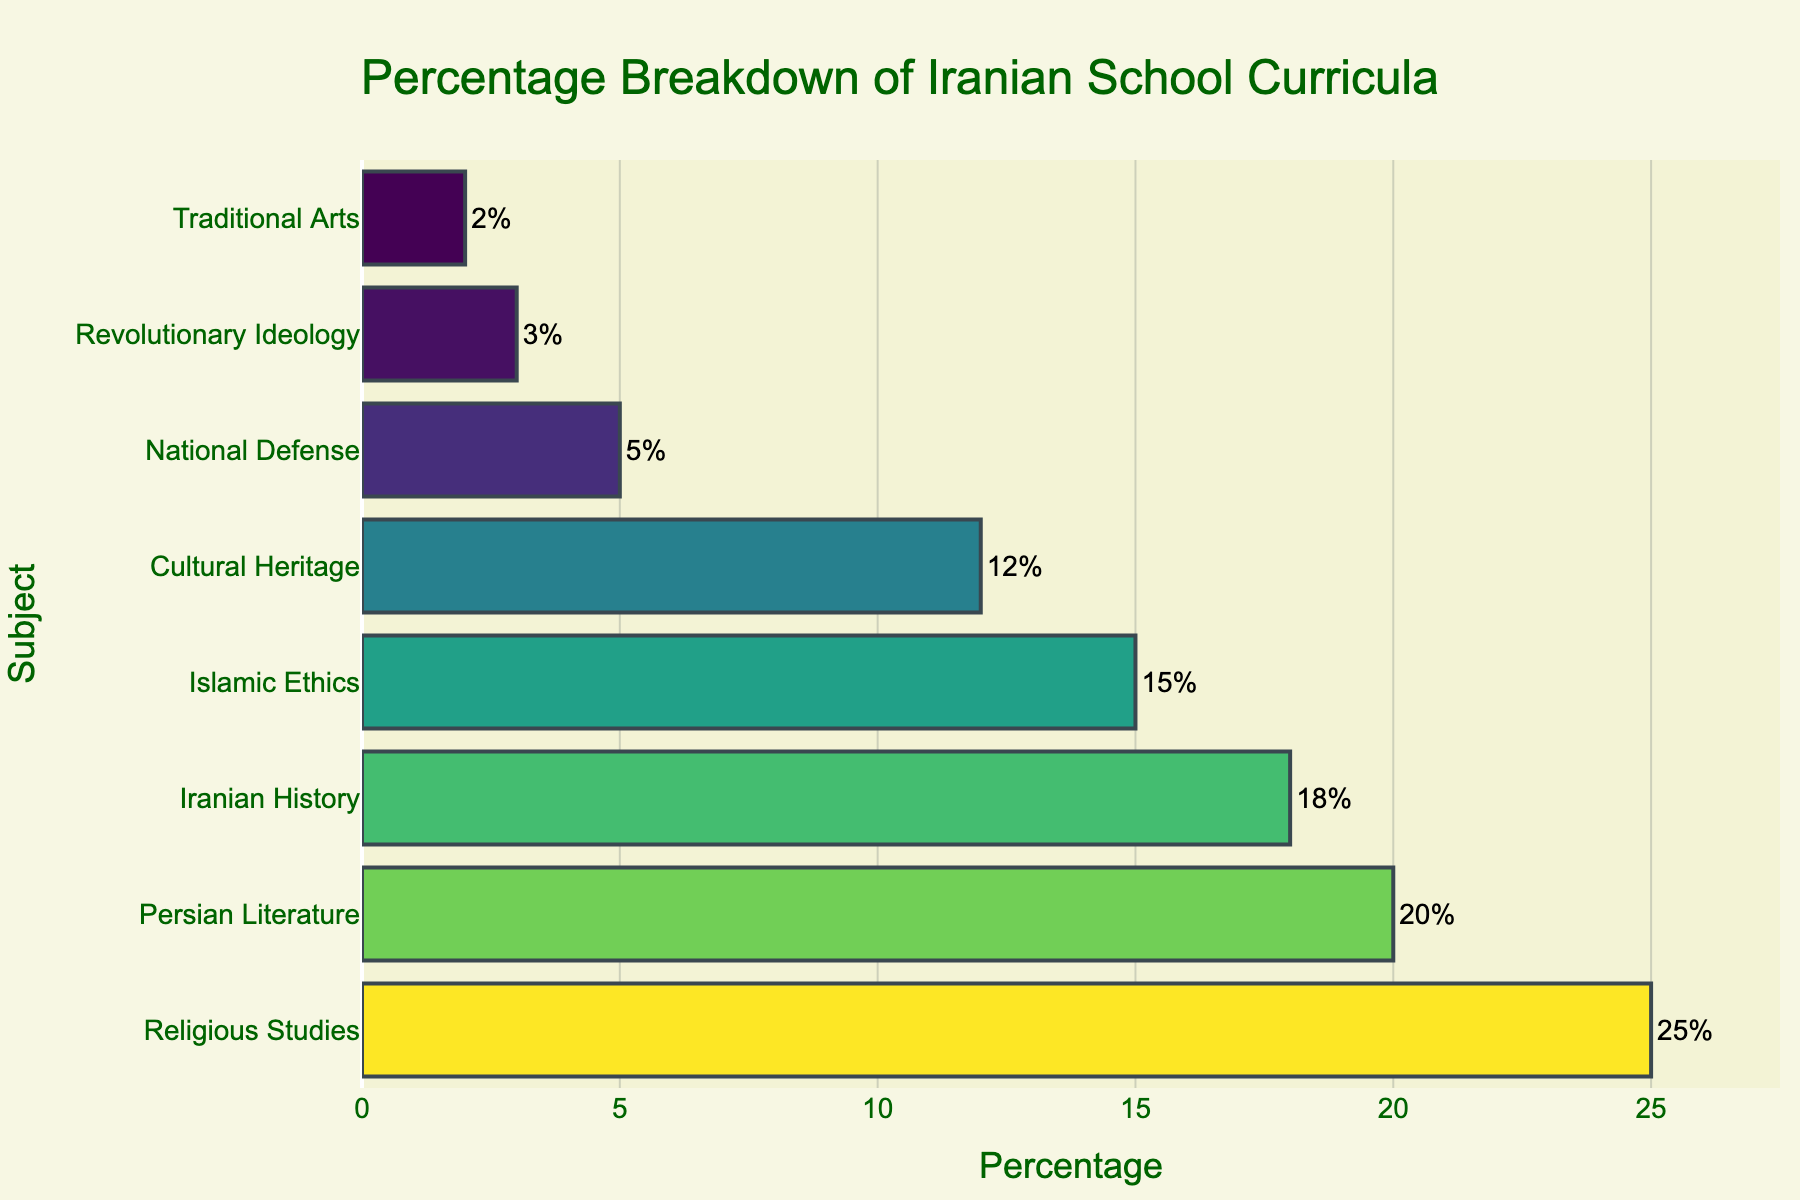Which subject has the highest percentage in the Iranian school curricula? Look at the bar representing the highest value on the horizontal axis. The subject with the highest percentage is Religious Studies with 25%.
Answer: Religious Studies How many subjects have a percentage higher than 15%? Locate the subjects on the y-axis. Count the bars that extend beyond the 15% mark on the x-axis. There are 4 bars: Religious Studies, Persian Literature, Iranian History, and Islamic Ethics.
Answer: 4 What is the combined percentage of Persian Literature and Cultural Heritage? Identify the percentages for Persian Literature (20%) and Cultural Heritage (12%). Sum them: 20% + 12% = 32%.
Answer: 32% Which subject is allocated the least percentage in the curriculum? Locate the bar with the shortest length on the x-axis. The subject with the least percentage is Traditional Arts with 2%.
Answer: Traditional Arts How much more percentage is given to Islamic Ethics compared to National Defense? Identify the percentages for Islamic Ethics (15%) and National Defense (5%). Calculate the difference: 15% - 5% = 10%.
Answer: 10% What is the average percentage across all subjects? Sum the percentages of all subjects and then divide by the number of subjects: (25% + 20% + 18% + 15% + 12% + 5% + 3% + 2%) / 8. The total is 100%, so the average is 100% / 8 = 12.5%.
Answer: 12.5% Which subjects contribute to more than 50% of the curriculum when combined? Add the percentages of subjects starting from the highest until the sum exceeds 50%. Religious Studies (25%) + Persian Literature (20%) + Iranian History (18%) = 63%. These three subjects combined account for more than 50%.
Answer: Religious Studies, Persian Literature, Iranian History Are there more subjects with a percentage below or above 10%? Count the subjects above 10% and below 10%. Above 10%: 5 subjects (Religious Studies, Persian Literature, Iranian History, Islamic Ethics, Cultural Heritage). Below 10%: 3 subjects (National Defense, Revolutionary Ideology, Traditional Arts).
Answer: Above, 5 subjects What is the difference in percentage allocation between the subject with the highest percentage and the subject with the lowest percentage? Identify the highest (Religious Studies, 25%) and lowest (Traditional Arts, 2%) percentages. Calculate the difference: 25% - 2% = 23%.
Answer: 23% Which subjects are related to Iran's national identity and culture? Identify subjects directly tied to Iran's cultural and historical background: Persian Literature, Iranian History, Cultural Heritage, National Defense, and Revolutionary Ideology.
Answer: Persian Literature, Iranian History, Cultural Heritage, National Defense, Revolutionary Ideology 